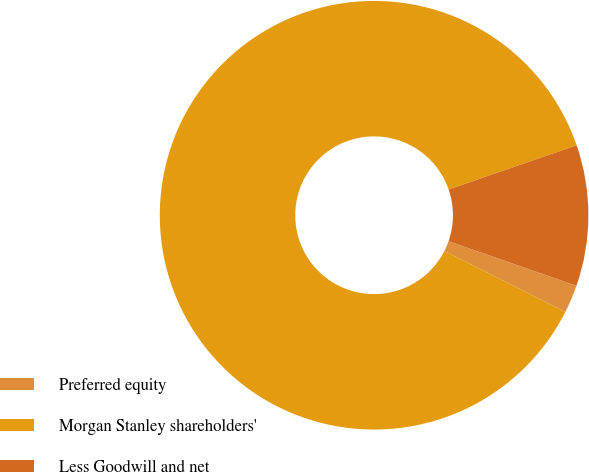Convert chart. <chart><loc_0><loc_0><loc_500><loc_500><pie_chart><fcel>Preferred equity<fcel>Morgan Stanley shareholders'<fcel>Less Goodwill and net<nl><fcel>2.12%<fcel>87.25%<fcel>10.63%<nl></chart> 